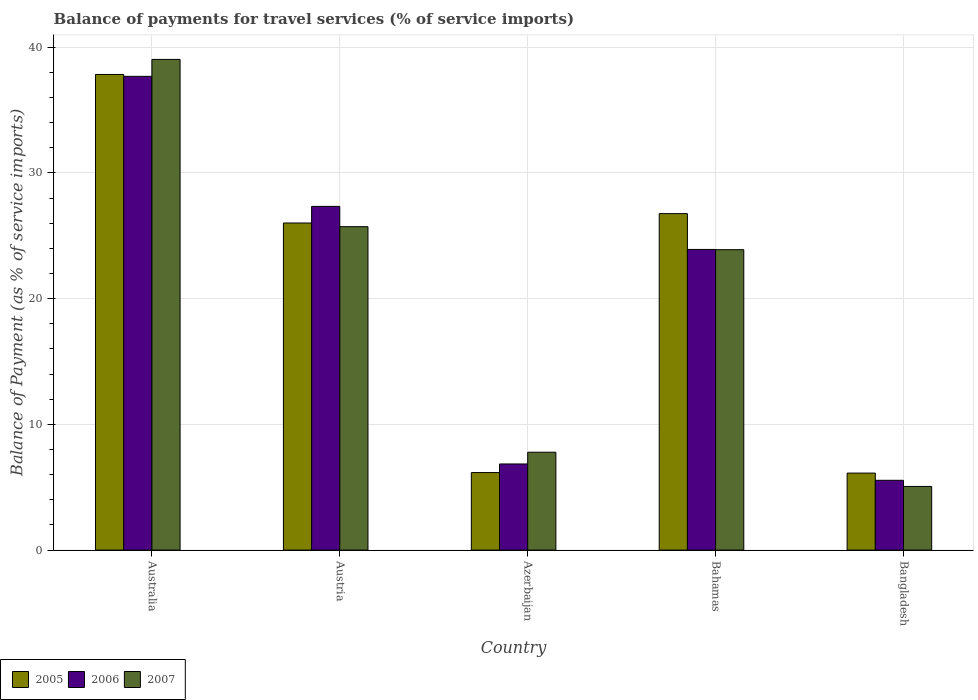How many different coloured bars are there?
Provide a succinct answer. 3. How many bars are there on the 1st tick from the right?
Keep it short and to the point. 3. What is the balance of payments for travel services in 2006 in Australia?
Provide a short and direct response. 37.68. Across all countries, what is the maximum balance of payments for travel services in 2006?
Your answer should be compact. 37.68. Across all countries, what is the minimum balance of payments for travel services in 2007?
Offer a terse response. 5.06. In which country was the balance of payments for travel services in 2006 maximum?
Offer a terse response. Australia. In which country was the balance of payments for travel services in 2007 minimum?
Your answer should be compact. Bangladesh. What is the total balance of payments for travel services in 2006 in the graph?
Provide a succinct answer. 101.34. What is the difference between the balance of payments for travel services in 2006 in Australia and that in Bahamas?
Make the answer very short. 13.77. What is the difference between the balance of payments for travel services in 2006 in Austria and the balance of payments for travel services in 2005 in Australia?
Give a very brief answer. -10.49. What is the average balance of payments for travel services in 2007 per country?
Your answer should be compact. 20.3. What is the difference between the balance of payments for travel services of/in 2007 and balance of payments for travel services of/in 2006 in Austria?
Offer a terse response. -1.61. In how many countries, is the balance of payments for travel services in 2005 greater than 10 %?
Offer a terse response. 3. What is the ratio of the balance of payments for travel services in 2005 in Azerbaijan to that in Bahamas?
Your response must be concise. 0.23. What is the difference between the highest and the second highest balance of payments for travel services in 2007?
Keep it short and to the point. 1.83. What is the difference between the highest and the lowest balance of payments for travel services in 2006?
Make the answer very short. 32.13. What does the 3rd bar from the right in Azerbaijan represents?
Make the answer very short. 2005. How many bars are there?
Your answer should be compact. 15. Are all the bars in the graph horizontal?
Keep it short and to the point. No. What is the difference between two consecutive major ticks on the Y-axis?
Offer a very short reply. 10. Are the values on the major ticks of Y-axis written in scientific E-notation?
Offer a terse response. No. Does the graph contain grids?
Keep it short and to the point. Yes. How many legend labels are there?
Your answer should be very brief. 3. What is the title of the graph?
Your answer should be very brief. Balance of payments for travel services (% of service imports). What is the label or title of the Y-axis?
Keep it short and to the point. Balance of Payment (as % of service imports). What is the Balance of Payment (as % of service imports) of 2005 in Australia?
Your response must be concise. 37.83. What is the Balance of Payment (as % of service imports) of 2006 in Australia?
Your response must be concise. 37.68. What is the Balance of Payment (as % of service imports) in 2007 in Australia?
Give a very brief answer. 39.03. What is the Balance of Payment (as % of service imports) of 2005 in Austria?
Keep it short and to the point. 26.02. What is the Balance of Payment (as % of service imports) in 2006 in Austria?
Keep it short and to the point. 27.34. What is the Balance of Payment (as % of service imports) in 2007 in Austria?
Your answer should be very brief. 25.73. What is the Balance of Payment (as % of service imports) of 2005 in Azerbaijan?
Your response must be concise. 6.17. What is the Balance of Payment (as % of service imports) in 2006 in Azerbaijan?
Provide a succinct answer. 6.85. What is the Balance of Payment (as % of service imports) in 2007 in Azerbaijan?
Offer a terse response. 7.79. What is the Balance of Payment (as % of service imports) of 2005 in Bahamas?
Offer a terse response. 26.76. What is the Balance of Payment (as % of service imports) in 2006 in Bahamas?
Offer a very short reply. 23.92. What is the Balance of Payment (as % of service imports) in 2007 in Bahamas?
Provide a short and direct response. 23.89. What is the Balance of Payment (as % of service imports) of 2005 in Bangladesh?
Ensure brevity in your answer.  6.13. What is the Balance of Payment (as % of service imports) in 2006 in Bangladesh?
Your answer should be compact. 5.55. What is the Balance of Payment (as % of service imports) in 2007 in Bangladesh?
Keep it short and to the point. 5.06. Across all countries, what is the maximum Balance of Payment (as % of service imports) of 2005?
Provide a short and direct response. 37.83. Across all countries, what is the maximum Balance of Payment (as % of service imports) of 2006?
Your response must be concise. 37.68. Across all countries, what is the maximum Balance of Payment (as % of service imports) in 2007?
Keep it short and to the point. 39.03. Across all countries, what is the minimum Balance of Payment (as % of service imports) of 2005?
Provide a succinct answer. 6.13. Across all countries, what is the minimum Balance of Payment (as % of service imports) of 2006?
Your answer should be compact. 5.55. Across all countries, what is the minimum Balance of Payment (as % of service imports) in 2007?
Your answer should be compact. 5.06. What is the total Balance of Payment (as % of service imports) of 2005 in the graph?
Keep it short and to the point. 102.91. What is the total Balance of Payment (as % of service imports) in 2006 in the graph?
Ensure brevity in your answer.  101.34. What is the total Balance of Payment (as % of service imports) of 2007 in the graph?
Make the answer very short. 101.5. What is the difference between the Balance of Payment (as % of service imports) of 2005 in Australia and that in Austria?
Ensure brevity in your answer.  11.82. What is the difference between the Balance of Payment (as % of service imports) in 2006 in Australia and that in Austria?
Your answer should be compact. 10.34. What is the difference between the Balance of Payment (as % of service imports) in 2007 in Australia and that in Austria?
Keep it short and to the point. 13.31. What is the difference between the Balance of Payment (as % of service imports) of 2005 in Australia and that in Azerbaijan?
Offer a terse response. 31.67. What is the difference between the Balance of Payment (as % of service imports) in 2006 in Australia and that in Azerbaijan?
Your answer should be compact. 30.83. What is the difference between the Balance of Payment (as % of service imports) in 2007 in Australia and that in Azerbaijan?
Provide a short and direct response. 31.24. What is the difference between the Balance of Payment (as % of service imports) of 2005 in Australia and that in Bahamas?
Provide a short and direct response. 11.07. What is the difference between the Balance of Payment (as % of service imports) in 2006 in Australia and that in Bahamas?
Your response must be concise. 13.77. What is the difference between the Balance of Payment (as % of service imports) in 2007 in Australia and that in Bahamas?
Keep it short and to the point. 15.14. What is the difference between the Balance of Payment (as % of service imports) in 2005 in Australia and that in Bangladesh?
Your response must be concise. 31.71. What is the difference between the Balance of Payment (as % of service imports) in 2006 in Australia and that in Bangladesh?
Ensure brevity in your answer.  32.13. What is the difference between the Balance of Payment (as % of service imports) in 2007 in Australia and that in Bangladesh?
Your answer should be very brief. 33.97. What is the difference between the Balance of Payment (as % of service imports) of 2005 in Austria and that in Azerbaijan?
Offer a very short reply. 19.85. What is the difference between the Balance of Payment (as % of service imports) in 2006 in Austria and that in Azerbaijan?
Offer a very short reply. 20.49. What is the difference between the Balance of Payment (as % of service imports) of 2007 in Austria and that in Azerbaijan?
Provide a short and direct response. 17.94. What is the difference between the Balance of Payment (as % of service imports) in 2005 in Austria and that in Bahamas?
Keep it short and to the point. -0.75. What is the difference between the Balance of Payment (as % of service imports) of 2006 in Austria and that in Bahamas?
Ensure brevity in your answer.  3.42. What is the difference between the Balance of Payment (as % of service imports) in 2007 in Austria and that in Bahamas?
Your answer should be very brief. 1.83. What is the difference between the Balance of Payment (as % of service imports) of 2005 in Austria and that in Bangladesh?
Offer a very short reply. 19.89. What is the difference between the Balance of Payment (as % of service imports) in 2006 in Austria and that in Bangladesh?
Your answer should be compact. 21.79. What is the difference between the Balance of Payment (as % of service imports) in 2007 in Austria and that in Bangladesh?
Ensure brevity in your answer.  20.66. What is the difference between the Balance of Payment (as % of service imports) of 2005 in Azerbaijan and that in Bahamas?
Your answer should be very brief. -20.6. What is the difference between the Balance of Payment (as % of service imports) in 2006 in Azerbaijan and that in Bahamas?
Provide a short and direct response. -17.06. What is the difference between the Balance of Payment (as % of service imports) in 2007 in Azerbaijan and that in Bahamas?
Provide a succinct answer. -16.11. What is the difference between the Balance of Payment (as % of service imports) in 2005 in Azerbaijan and that in Bangladesh?
Give a very brief answer. 0.04. What is the difference between the Balance of Payment (as % of service imports) in 2006 in Azerbaijan and that in Bangladesh?
Offer a very short reply. 1.3. What is the difference between the Balance of Payment (as % of service imports) of 2007 in Azerbaijan and that in Bangladesh?
Your answer should be compact. 2.72. What is the difference between the Balance of Payment (as % of service imports) in 2005 in Bahamas and that in Bangladesh?
Provide a succinct answer. 20.64. What is the difference between the Balance of Payment (as % of service imports) in 2006 in Bahamas and that in Bangladesh?
Your answer should be very brief. 18.36. What is the difference between the Balance of Payment (as % of service imports) of 2007 in Bahamas and that in Bangladesh?
Give a very brief answer. 18.83. What is the difference between the Balance of Payment (as % of service imports) in 2005 in Australia and the Balance of Payment (as % of service imports) in 2006 in Austria?
Ensure brevity in your answer.  10.49. What is the difference between the Balance of Payment (as % of service imports) in 2005 in Australia and the Balance of Payment (as % of service imports) in 2007 in Austria?
Make the answer very short. 12.11. What is the difference between the Balance of Payment (as % of service imports) of 2006 in Australia and the Balance of Payment (as % of service imports) of 2007 in Austria?
Your answer should be compact. 11.96. What is the difference between the Balance of Payment (as % of service imports) in 2005 in Australia and the Balance of Payment (as % of service imports) in 2006 in Azerbaijan?
Your answer should be very brief. 30.98. What is the difference between the Balance of Payment (as % of service imports) of 2005 in Australia and the Balance of Payment (as % of service imports) of 2007 in Azerbaijan?
Your answer should be compact. 30.05. What is the difference between the Balance of Payment (as % of service imports) in 2006 in Australia and the Balance of Payment (as % of service imports) in 2007 in Azerbaijan?
Provide a short and direct response. 29.9. What is the difference between the Balance of Payment (as % of service imports) of 2005 in Australia and the Balance of Payment (as % of service imports) of 2006 in Bahamas?
Offer a very short reply. 13.92. What is the difference between the Balance of Payment (as % of service imports) in 2005 in Australia and the Balance of Payment (as % of service imports) in 2007 in Bahamas?
Your answer should be compact. 13.94. What is the difference between the Balance of Payment (as % of service imports) in 2006 in Australia and the Balance of Payment (as % of service imports) in 2007 in Bahamas?
Make the answer very short. 13.79. What is the difference between the Balance of Payment (as % of service imports) in 2005 in Australia and the Balance of Payment (as % of service imports) in 2006 in Bangladesh?
Provide a succinct answer. 32.28. What is the difference between the Balance of Payment (as % of service imports) in 2005 in Australia and the Balance of Payment (as % of service imports) in 2007 in Bangladesh?
Your answer should be very brief. 32.77. What is the difference between the Balance of Payment (as % of service imports) in 2006 in Australia and the Balance of Payment (as % of service imports) in 2007 in Bangladesh?
Your answer should be compact. 32.62. What is the difference between the Balance of Payment (as % of service imports) in 2005 in Austria and the Balance of Payment (as % of service imports) in 2006 in Azerbaijan?
Provide a succinct answer. 19.17. What is the difference between the Balance of Payment (as % of service imports) in 2005 in Austria and the Balance of Payment (as % of service imports) in 2007 in Azerbaijan?
Give a very brief answer. 18.23. What is the difference between the Balance of Payment (as % of service imports) in 2006 in Austria and the Balance of Payment (as % of service imports) in 2007 in Azerbaijan?
Your answer should be compact. 19.55. What is the difference between the Balance of Payment (as % of service imports) of 2005 in Austria and the Balance of Payment (as % of service imports) of 2006 in Bahamas?
Provide a short and direct response. 2.1. What is the difference between the Balance of Payment (as % of service imports) of 2005 in Austria and the Balance of Payment (as % of service imports) of 2007 in Bahamas?
Your response must be concise. 2.12. What is the difference between the Balance of Payment (as % of service imports) of 2006 in Austria and the Balance of Payment (as % of service imports) of 2007 in Bahamas?
Offer a terse response. 3.44. What is the difference between the Balance of Payment (as % of service imports) of 2005 in Austria and the Balance of Payment (as % of service imports) of 2006 in Bangladesh?
Provide a succinct answer. 20.47. What is the difference between the Balance of Payment (as % of service imports) in 2005 in Austria and the Balance of Payment (as % of service imports) in 2007 in Bangladesh?
Provide a short and direct response. 20.95. What is the difference between the Balance of Payment (as % of service imports) in 2006 in Austria and the Balance of Payment (as % of service imports) in 2007 in Bangladesh?
Your response must be concise. 22.27. What is the difference between the Balance of Payment (as % of service imports) in 2005 in Azerbaijan and the Balance of Payment (as % of service imports) in 2006 in Bahamas?
Your response must be concise. -17.75. What is the difference between the Balance of Payment (as % of service imports) in 2005 in Azerbaijan and the Balance of Payment (as % of service imports) in 2007 in Bahamas?
Provide a succinct answer. -17.73. What is the difference between the Balance of Payment (as % of service imports) of 2006 in Azerbaijan and the Balance of Payment (as % of service imports) of 2007 in Bahamas?
Make the answer very short. -17.04. What is the difference between the Balance of Payment (as % of service imports) in 2005 in Azerbaijan and the Balance of Payment (as % of service imports) in 2006 in Bangladesh?
Provide a succinct answer. 0.61. What is the difference between the Balance of Payment (as % of service imports) in 2005 in Azerbaijan and the Balance of Payment (as % of service imports) in 2007 in Bangladesh?
Give a very brief answer. 1.1. What is the difference between the Balance of Payment (as % of service imports) of 2006 in Azerbaijan and the Balance of Payment (as % of service imports) of 2007 in Bangladesh?
Ensure brevity in your answer.  1.79. What is the difference between the Balance of Payment (as % of service imports) in 2005 in Bahamas and the Balance of Payment (as % of service imports) in 2006 in Bangladesh?
Ensure brevity in your answer.  21.21. What is the difference between the Balance of Payment (as % of service imports) in 2005 in Bahamas and the Balance of Payment (as % of service imports) in 2007 in Bangladesh?
Provide a short and direct response. 21.7. What is the difference between the Balance of Payment (as % of service imports) in 2006 in Bahamas and the Balance of Payment (as % of service imports) in 2007 in Bangladesh?
Provide a short and direct response. 18.85. What is the average Balance of Payment (as % of service imports) of 2005 per country?
Provide a succinct answer. 20.58. What is the average Balance of Payment (as % of service imports) in 2006 per country?
Give a very brief answer. 20.27. What is the average Balance of Payment (as % of service imports) of 2007 per country?
Make the answer very short. 20.3. What is the difference between the Balance of Payment (as % of service imports) in 2005 and Balance of Payment (as % of service imports) in 2006 in Australia?
Make the answer very short. 0.15. What is the difference between the Balance of Payment (as % of service imports) in 2005 and Balance of Payment (as % of service imports) in 2007 in Australia?
Your answer should be compact. -1.2. What is the difference between the Balance of Payment (as % of service imports) in 2006 and Balance of Payment (as % of service imports) in 2007 in Australia?
Provide a short and direct response. -1.35. What is the difference between the Balance of Payment (as % of service imports) of 2005 and Balance of Payment (as % of service imports) of 2006 in Austria?
Provide a succinct answer. -1.32. What is the difference between the Balance of Payment (as % of service imports) of 2005 and Balance of Payment (as % of service imports) of 2007 in Austria?
Ensure brevity in your answer.  0.29. What is the difference between the Balance of Payment (as % of service imports) of 2006 and Balance of Payment (as % of service imports) of 2007 in Austria?
Offer a very short reply. 1.61. What is the difference between the Balance of Payment (as % of service imports) in 2005 and Balance of Payment (as % of service imports) in 2006 in Azerbaijan?
Provide a short and direct response. -0.69. What is the difference between the Balance of Payment (as % of service imports) in 2005 and Balance of Payment (as % of service imports) in 2007 in Azerbaijan?
Keep it short and to the point. -1.62. What is the difference between the Balance of Payment (as % of service imports) in 2006 and Balance of Payment (as % of service imports) in 2007 in Azerbaijan?
Keep it short and to the point. -0.93. What is the difference between the Balance of Payment (as % of service imports) in 2005 and Balance of Payment (as % of service imports) in 2006 in Bahamas?
Offer a very short reply. 2.85. What is the difference between the Balance of Payment (as % of service imports) of 2005 and Balance of Payment (as % of service imports) of 2007 in Bahamas?
Provide a short and direct response. 2.87. What is the difference between the Balance of Payment (as % of service imports) in 2006 and Balance of Payment (as % of service imports) in 2007 in Bahamas?
Ensure brevity in your answer.  0.02. What is the difference between the Balance of Payment (as % of service imports) in 2005 and Balance of Payment (as % of service imports) in 2006 in Bangladesh?
Ensure brevity in your answer.  0.57. What is the difference between the Balance of Payment (as % of service imports) in 2005 and Balance of Payment (as % of service imports) in 2007 in Bangladesh?
Your response must be concise. 1.06. What is the difference between the Balance of Payment (as % of service imports) in 2006 and Balance of Payment (as % of service imports) in 2007 in Bangladesh?
Provide a succinct answer. 0.49. What is the ratio of the Balance of Payment (as % of service imports) of 2005 in Australia to that in Austria?
Give a very brief answer. 1.45. What is the ratio of the Balance of Payment (as % of service imports) in 2006 in Australia to that in Austria?
Offer a terse response. 1.38. What is the ratio of the Balance of Payment (as % of service imports) in 2007 in Australia to that in Austria?
Provide a succinct answer. 1.52. What is the ratio of the Balance of Payment (as % of service imports) of 2005 in Australia to that in Azerbaijan?
Provide a short and direct response. 6.14. What is the ratio of the Balance of Payment (as % of service imports) in 2006 in Australia to that in Azerbaijan?
Your answer should be compact. 5.5. What is the ratio of the Balance of Payment (as % of service imports) of 2007 in Australia to that in Azerbaijan?
Keep it short and to the point. 5.01. What is the ratio of the Balance of Payment (as % of service imports) of 2005 in Australia to that in Bahamas?
Ensure brevity in your answer.  1.41. What is the ratio of the Balance of Payment (as % of service imports) of 2006 in Australia to that in Bahamas?
Offer a very short reply. 1.58. What is the ratio of the Balance of Payment (as % of service imports) of 2007 in Australia to that in Bahamas?
Provide a short and direct response. 1.63. What is the ratio of the Balance of Payment (as % of service imports) of 2005 in Australia to that in Bangladesh?
Provide a short and direct response. 6.18. What is the ratio of the Balance of Payment (as % of service imports) in 2006 in Australia to that in Bangladesh?
Provide a succinct answer. 6.79. What is the ratio of the Balance of Payment (as % of service imports) of 2007 in Australia to that in Bangladesh?
Offer a very short reply. 7.71. What is the ratio of the Balance of Payment (as % of service imports) in 2005 in Austria to that in Azerbaijan?
Give a very brief answer. 4.22. What is the ratio of the Balance of Payment (as % of service imports) of 2006 in Austria to that in Azerbaijan?
Your response must be concise. 3.99. What is the ratio of the Balance of Payment (as % of service imports) in 2007 in Austria to that in Azerbaijan?
Offer a very short reply. 3.3. What is the ratio of the Balance of Payment (as % of service imports) of 2005 in Austria to that in Bahamas?
Give a very brief answer. 0.97. What is the ratio of the Balance of Payment (as % of service imports) in 2006 in Austria to that in Bahamas?
Offer a terse response. 1.14. What is the ratio of the Balance of Payment (as % of service imports) in 2007 in Austria to that in Bahamas?
Your answer should be very brief. 1.08. What is the ratio of the Balance of Payment (as % of service imports) in 2005 in Austria to that in Bangladesh?
Your answer should be very brief. 4.25. What is the ratio of the Balance of Payment (as % of service imports) in 2006 in Austria to that in Bangladesh?
Make the answer very short. 4.92. What is the ratio of the Balance of Payment (as % of service imports) of 2007 in Austria to that in Bangladesh?
Provide a succinct answer. 5.08. What is the ratio of the Balance of Payment (as % of service imports) in 2005 in Azerbaijan to that in Bahamas?
Provide a short and direct response. 0.23. What is the ratio of the Balance of Payment (as % of service imports) in 2006 in Azerbaijan to that in Bahamas?
Ensure brevity in your answer.  0.29. What is the ratio of the Balance of Payment (as % of service imports) of 2007 in Azerbaijan to that in Bahamas?
Your response must be concise. 0.33. What is the ratio of the Balance of Payment (as % of service imports) of 2005 in Azerbaijan to that in Bangladesh?
Provide a short and direct response. 1.01. What is the ratio of the Balance of Payment (as % of service imports) of 2006 in Azerbaijan to that in Bangladesh?
Your answer should be very brief. 1.23. What is the ratio of the Balance of Payment (as % of service imports) of 2007 in Azerbaijan to that in Bangladesh?
Provide a succinct answer. 1.54. What is the ratio of the Balance of Payment (as % of service imports) of 2005 in Bahamas to that in Bangladesh?
Offer a terse response. 4.37. What is the ratio of the Balance of Payment (as % of service imports) of 2006 in Bahamas to that in Bangladesh?
Ensure brevity in your answer.  4.31. What is the ratio of the Balance of Payment (as % of service imports) of 2007 in Bahamas to that in Bangladesh?
Keep it short and to the point. 4.72. What is the difference between the highest and the second highest Balance of Payment (as % of service imports) in 2005?
Provide a succinct answer. 11.07. What is the difference between the highest and the second highest Balance of Payment (as % of service imports) in 2006?
Keep it short and to the point. 10.34. What is the difference between the highest and the second highest Balance of Payment (as % of service imports) of 2007?
Provide a succinct answer. 13.31. What is the difference between the highest and the lowest Balance of Payment (as % of service imports) of 2005?
Your response must be concise. 31.71. What is the difference between the highest and the lowest Balance of Payment (as % of service imports) of 2006?
Give a very brief answer. 32.13. What is the difference between the highest and the lowest Balance of Payment (as % of service imports) of 2007?
Your answer should be compact. 33.97. 